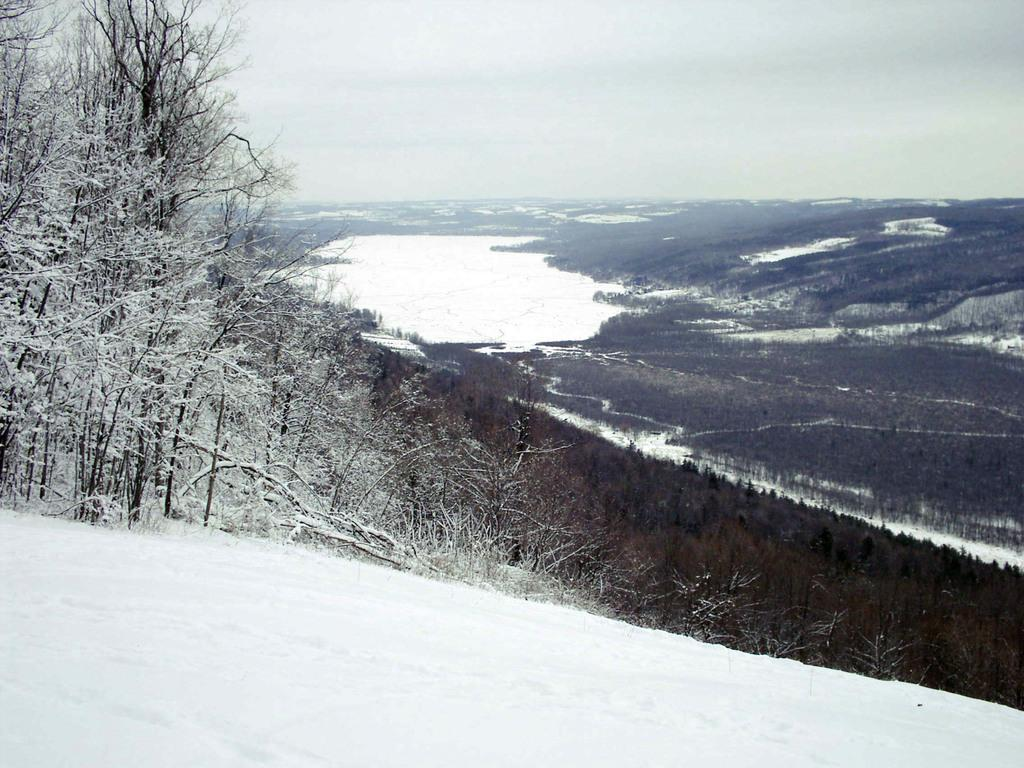What type of vegetation can be seen in the image? There are trees in the image. What is covering the trees in the image? The trees are covered with snow. What is visible at the top of the image? The sky is visible at the top of the image. What is present at the bottom of the image? Snow is present at the bottom of the image. Can you see a baby driving a car in the image? There is no baby or car present in the image. 